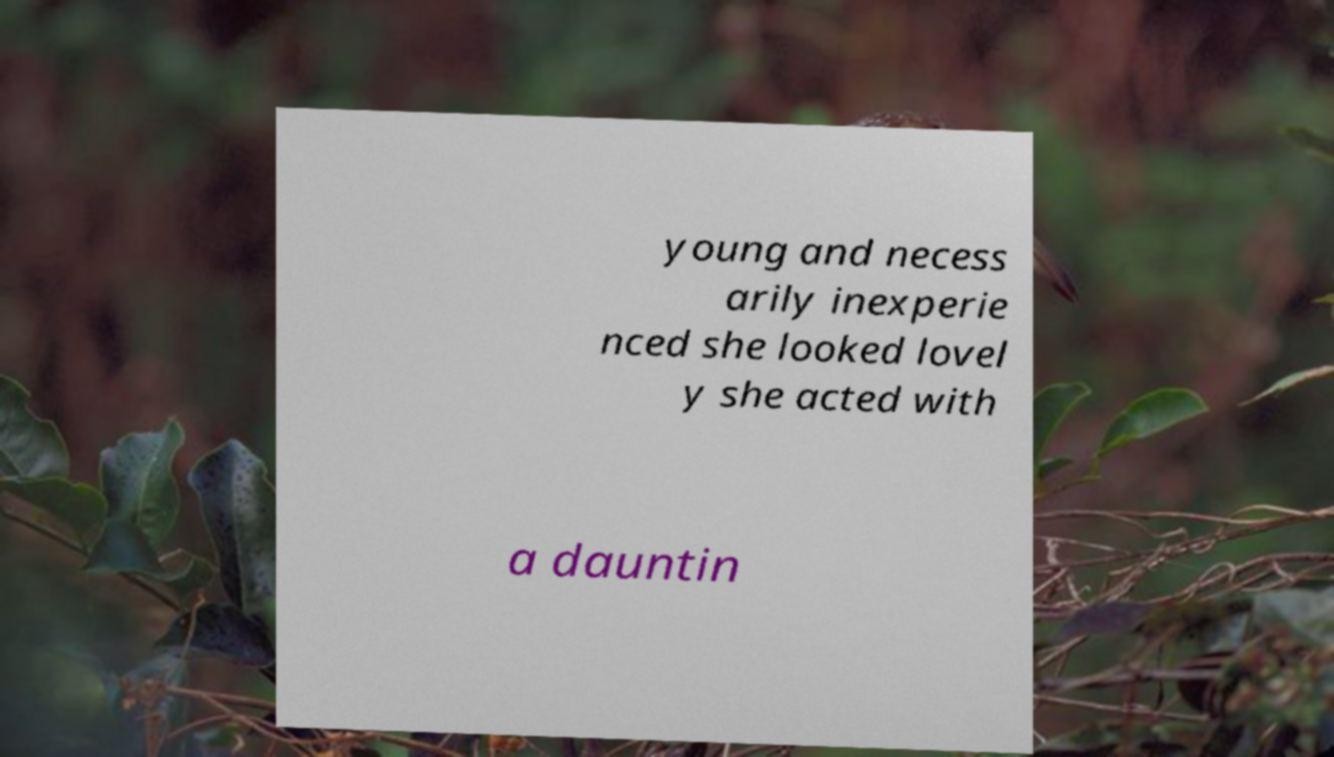For documentation purposes, I need the text within this image transcribed. Could you provide that? young and necess arily inexperie nced she looked lovel y she acted with a dauntin 